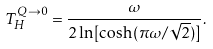<formula> <loc_0><loc_0><loc_500><loc_500>T _ { H } ^ { Q \to 0 } = { \frac { \omega } { 2 \ln [ \cosh ( \pi \omega / \sqrt { 2 } ) ] } } .</formula> 